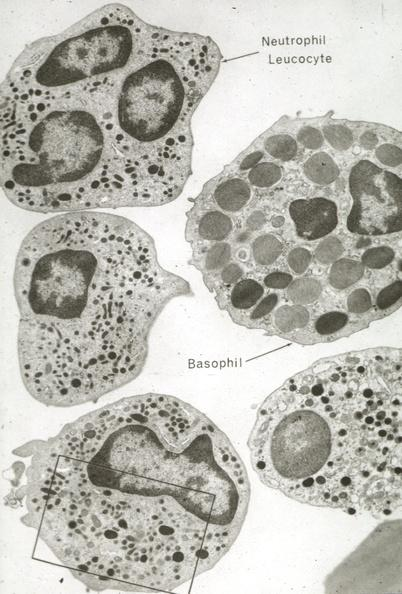s jejunum present?
Answer the question using a single word or phrase. No 